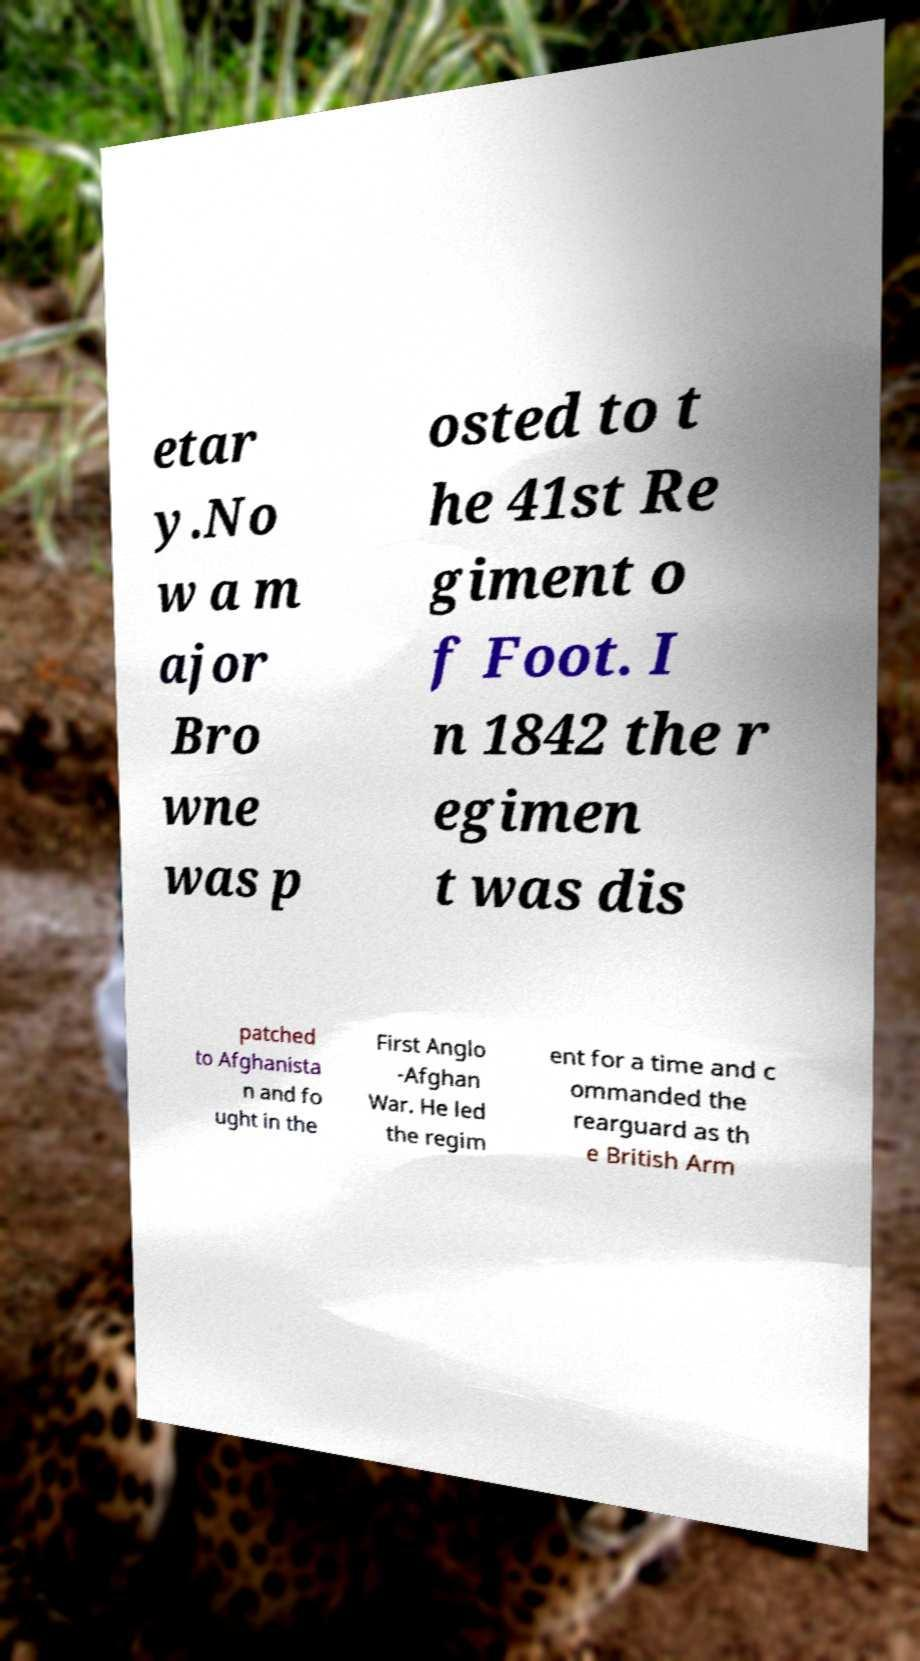Could you assist in decoding the text presented in this image and type it out clearly? etar y.No w a m ajor Bro wne was p osted to t he 41st Re giment o f Foot. I n 1842 the r egimen t was dis patched to Afghanista n and fo ught in the First Anglo -Afghan War. He led the regim ent for a time and c ommanded the rearguard as th e British Arm 